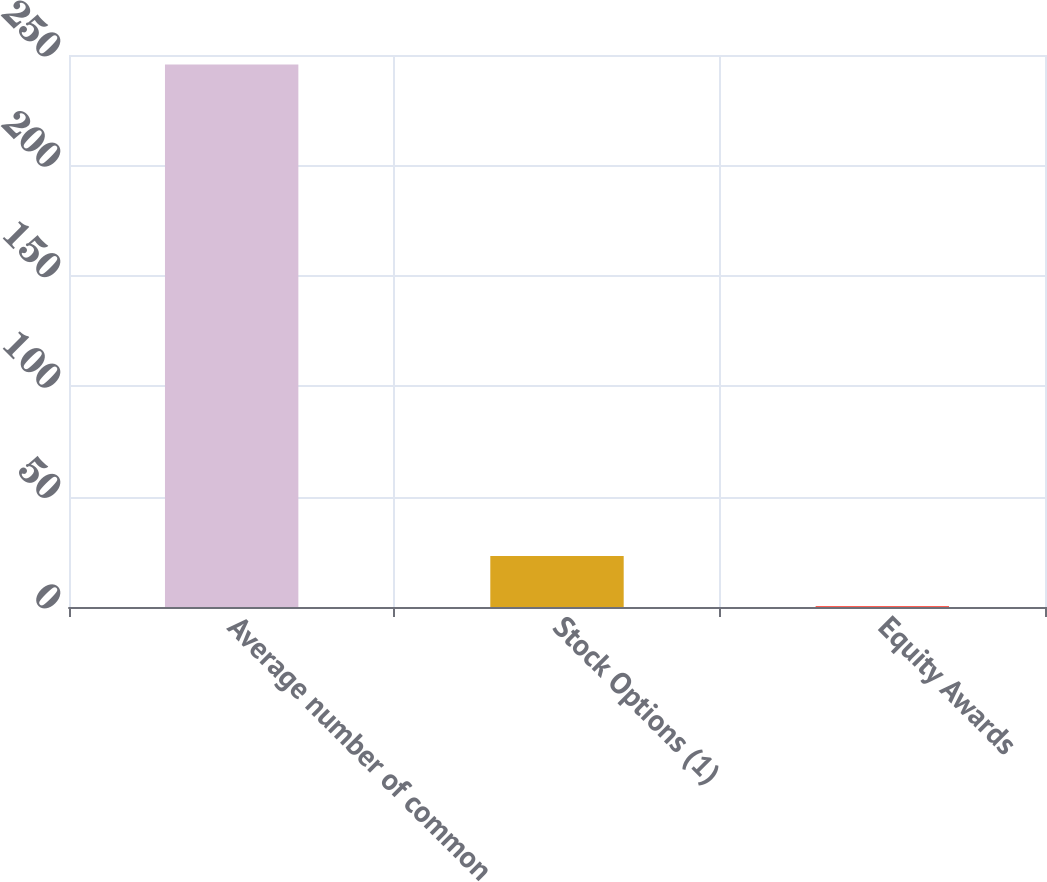Convert chart to OTSL. <chart><loc_0><loc_0><loc_500><loc_500><bar_chart><fcel>Average number of common<fcel>Stock Options (1)<fcel>Equity Awards<nl><fcel>245.69<fcel>23.09<fcel>0.4<nl></chart> 